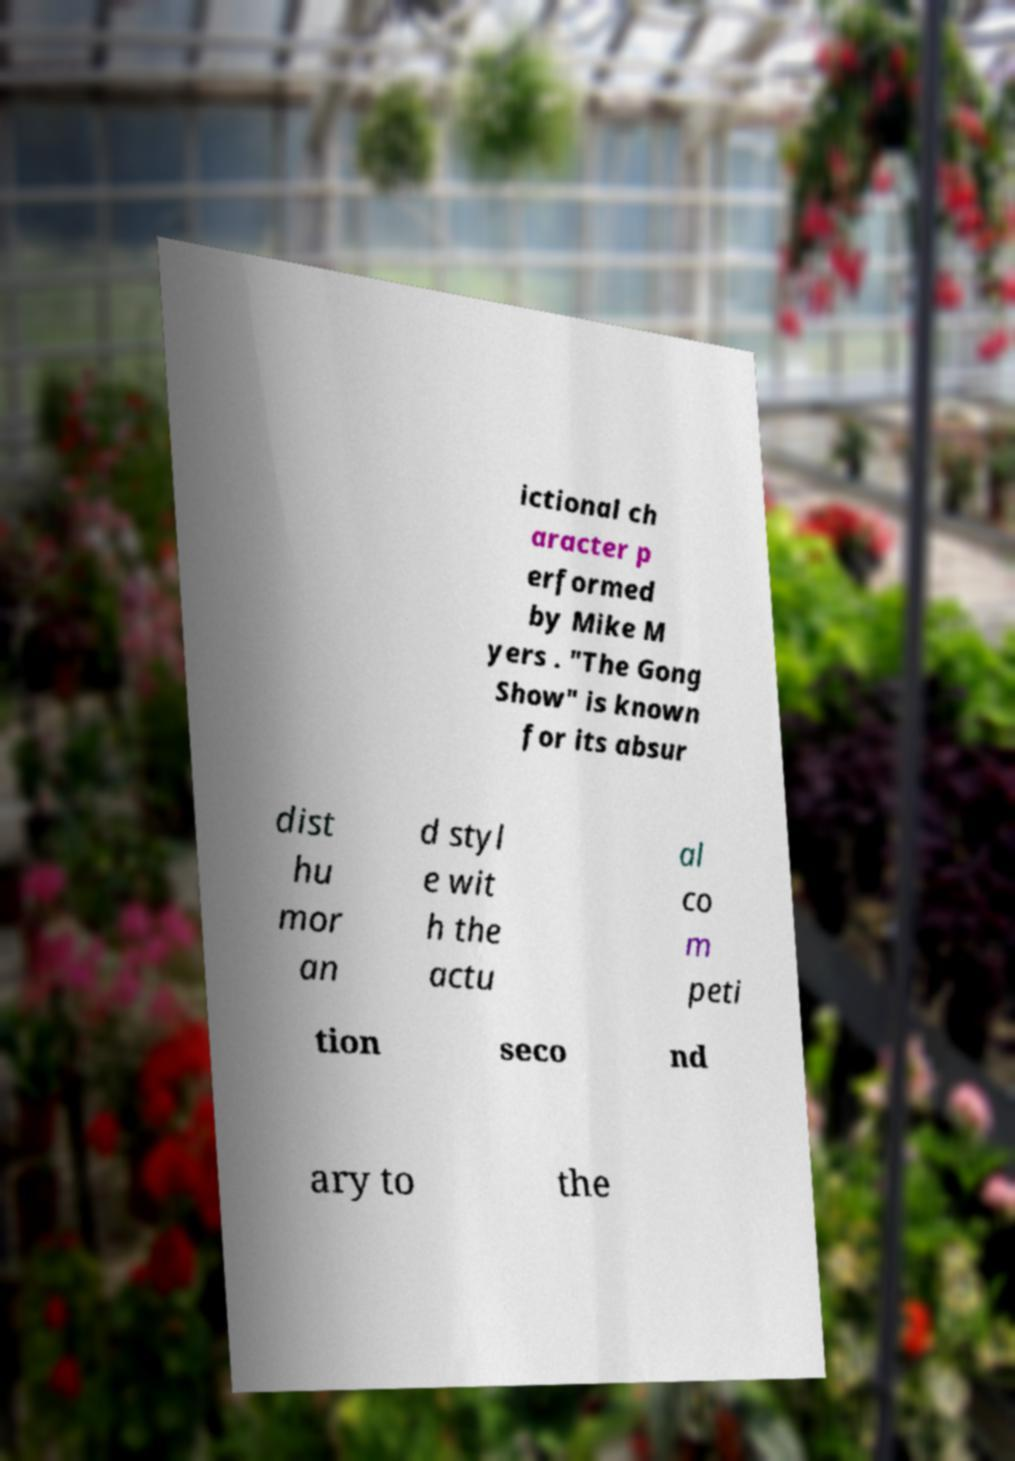I need the written content from this picture converted into text. Can you do that? ictional ch aracter p erformed by Mike M yers . "The Gong Show" is known for its absur dist hu mor an d styl e wit h the actu al co m peti tion seco nd ary to the 